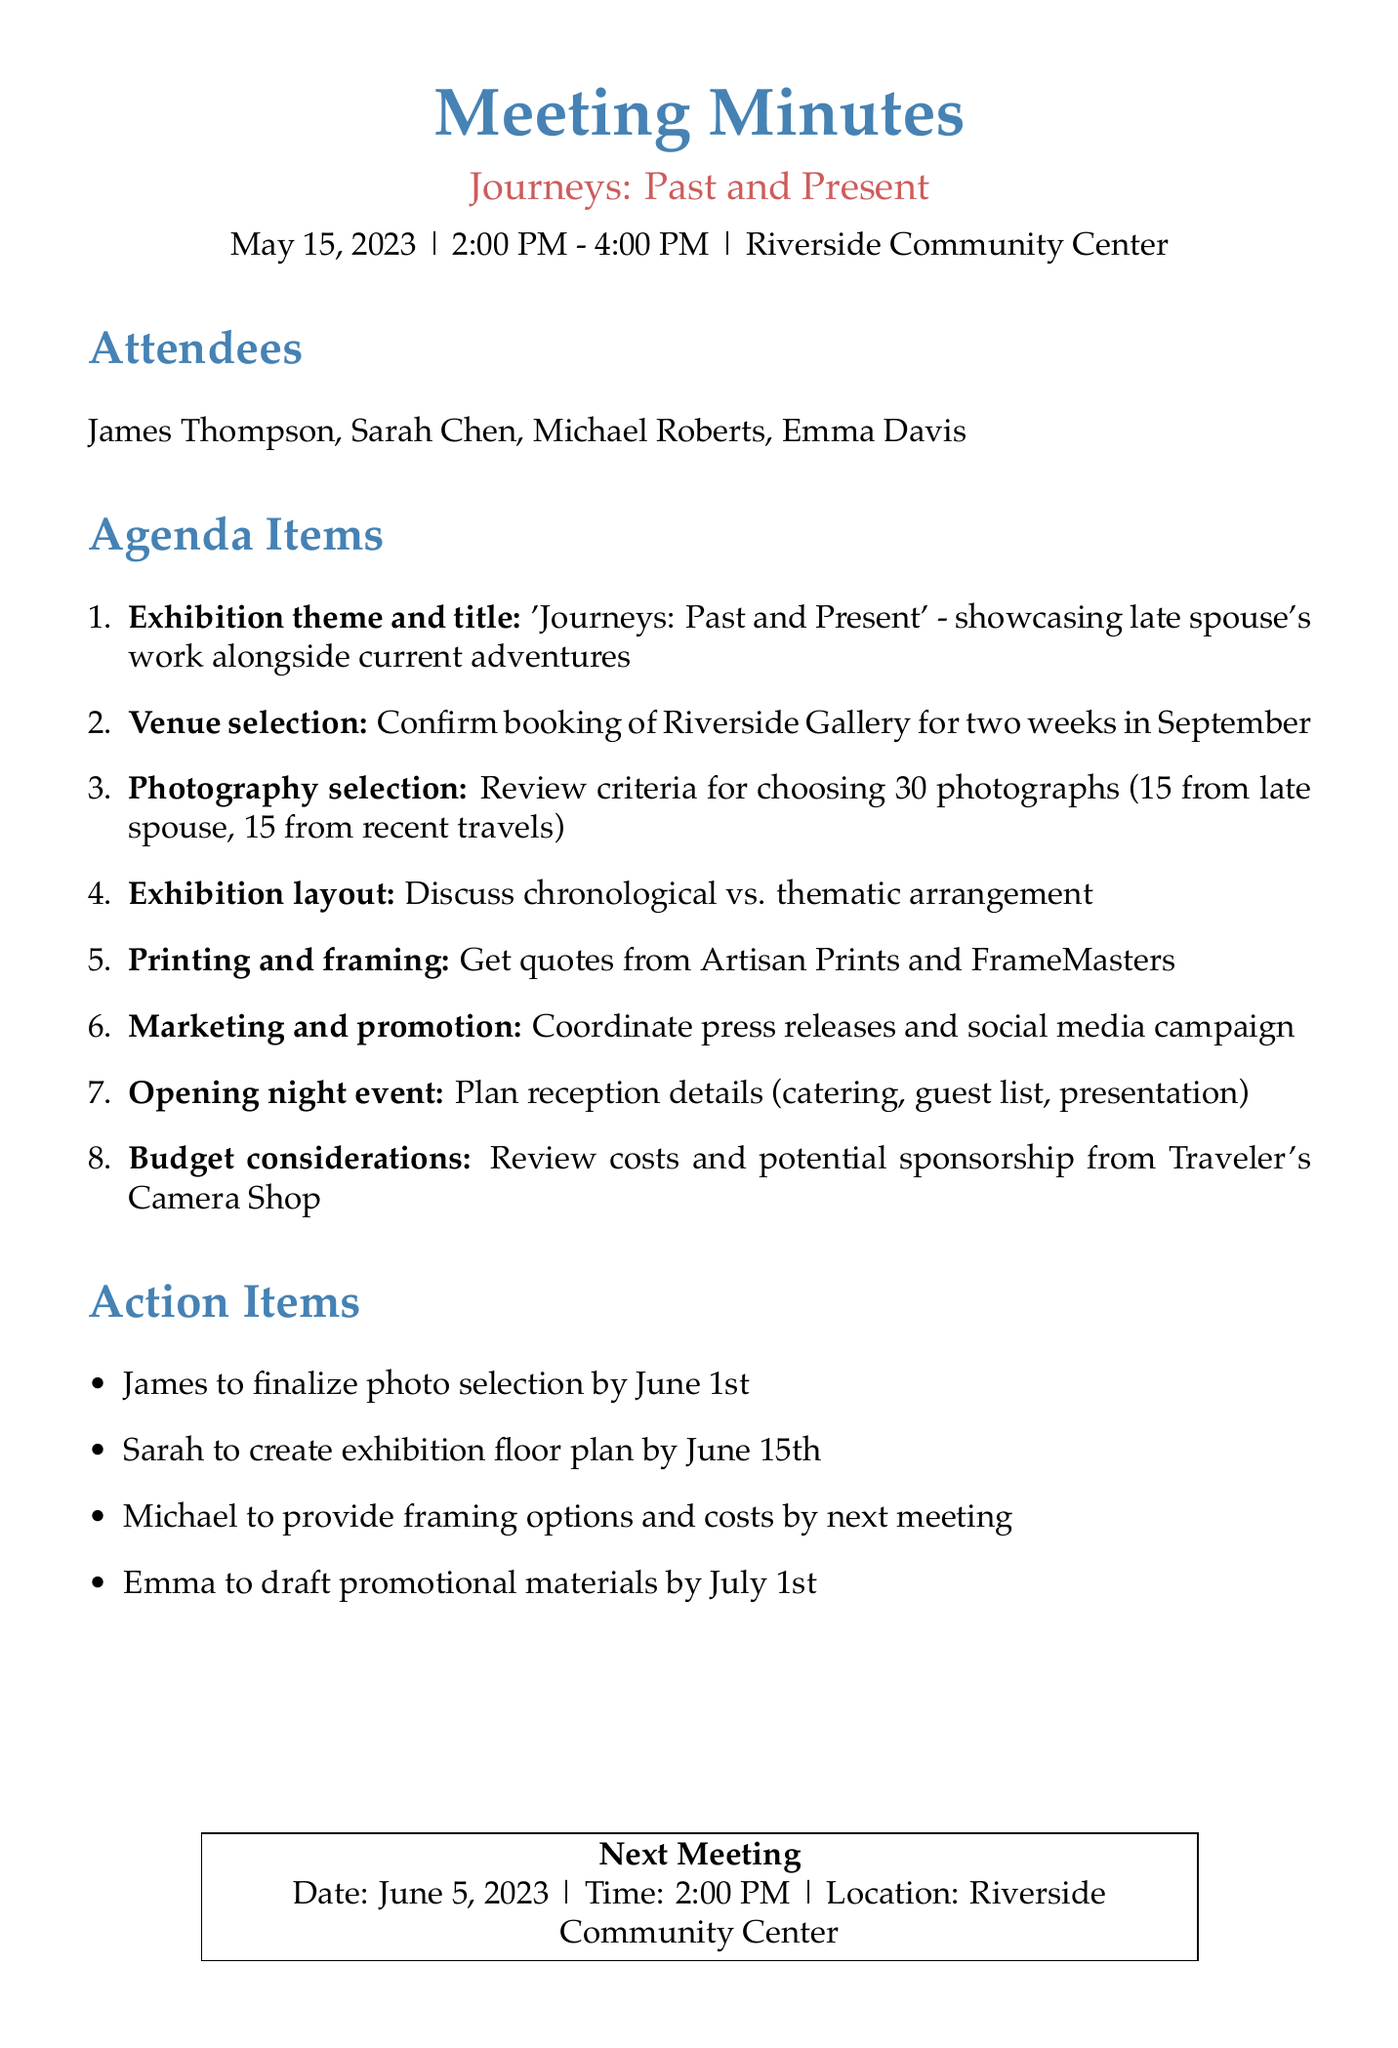What is the date of the meeting? The document explicitly states the meeting date in the meeting details section.
Answer: May 15, 2023 Who is the exhibition curator? The attendees section lists the individuals present, indicating their roles.
Answer: Sarah Chen What is the proposed title for the exhibition? The title is specified under the exhibition theme and title topic in the agenda.
Answer: 'Journeys: Past and Present' How many photographs will be chosen for the exhibition? The photography selection process outlines the total number of photographs to be selected.
Answer: 30 What are the local print shops mentioned for quotes? The printing and framing topic lists the names of the print shops to contact for quotes.
Answer: Artisan Prints and FrameMasters When is the next meeting scheduled? The next meeting date is detailed in a box toward the end of the document.
Answer: June 5, 2023 Who is responsible for drafting the promotional materials? The action items outline who is responsible for various tasks after the meeting.
Answer: Emma What should the theme of the exhibition emphasize? The exhibition theme concept highlights both past memories and current experiences.
Answer: Late spouse's work alongside current adventures 